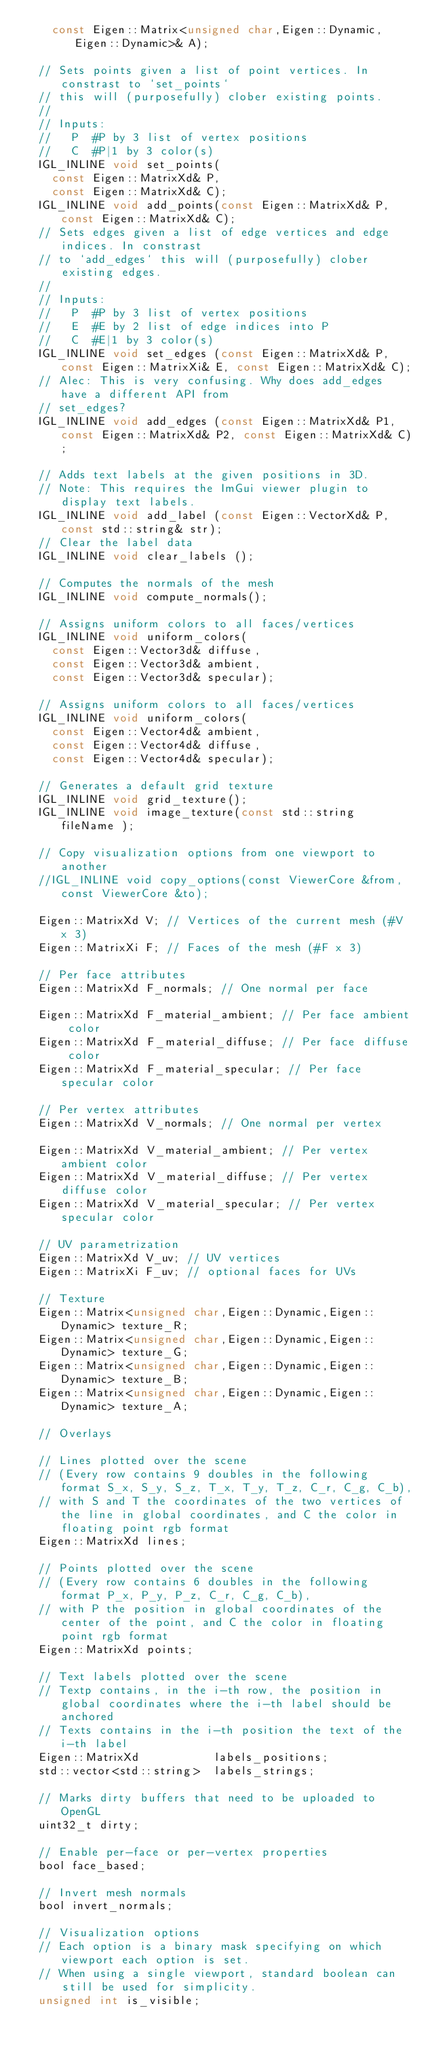Convert code to text. <code><loc_0><loc_0><loc_500><loc_500><_C_>    const Eigen::Matrix<unsigned char,Eigen::Dynamic,Eigen::Dynamic>& A);

  // Sets points given a list of point vertices. In constrast to `set_points`
  // this will (purposefully) clober existing points.
  //
  // Inputs:
  //   P  #P by 3 list of vertex positions
  //   C  #P|1 by 3 color(s)
  IGL_INLINE void set_points(
    const Eigen::MatrixXd& P,
    const Eigen::MatrixXd& C);
  IGL_INLINE void add_points(const Eigen::MatrixXd& P,  const Eigen::MatrixXd& C);
  // Sets edges given a list of edge vertices and edge indices. In constrast
  // to `add_edges` this will (purposefully) clober existing edges.
  //
  // Inputs:
  //   P  #P by 3 list of vertex positions
  //   E  #E by 2 list of edge indices into P
  //   C  #E|1 by 3 color(s)
  IGL_INLINE void set_edges (const Eigen::MatrixXd& P, const Eigen::MatrixXi& E, const Eigen::MatrixXd& C);
  // Alec: This is very confusing. Why does add_edges have a different API from
  // set_edges?
  IGL_INLINE void add_edges (const Eigen::MatrixXd& P1, const Eigen::MatrixXd& P2, const Eigen::MatrixXd& C);

  // Adds text labels at the given positions in 3D.
  // Note: This requires the ImGui viewer plugin to display text labels.
  IGL_INLINE void add_label (const Eigen::VectorXd& P,  const std::string& str);
  // Clear the label data
  IGL_INLINE void clear_labels ();

  // Computes the normals of the mesh
  IGL_INLINE void compute_normals();

  // Assigns uniform colors to all faces/vertices
  IGL_INLINE void uniform_colors(
    const Eigen::Vector3d& diffuse,
    const Eigen::Vector3d& ambient,
    const Eigen::Vector3d& specular);

  // Assigns uniform colors to all faces/vertices
  IGL_INLINE void uniform_colors(
    const Eigen::Vector4d& ambient,
    const Eigen::Vector4d& diffuse,
    const Eigen::Vector4d& specular);

  // Generates a default grid texture
  IGL_INLINE void grid_texture();
  IGL_INLINE void image_texture(const std::string fileName );

  // Copy visualization options from one viewport to another
  //IGL_INLINE void copy_options(const ViewerCore &from, const ViewerCore &to);

  Eigen::MatrixXd V; // Vertices of the current mesh (#V x 3)
  Eigen::MatrixXi F; // Faces of the mesh (#F x 3)

  // Per face attributes
  Eigen::MatrixXd F_normals; // One normal per face

  Eigen::MatrixXd F_material_ambient; // Per face ambient color
  Eigen::MatrixXd F_material_diffuse; // Per face diffuse color
  Eigen::MatrixXd F_material_specular; // Per face specular color

  // Per vertex attributes
  Eigen::MatrixXd V_normals; // One normal per vertex

  Eigen::MatrixXd V_material_ambient; // Per vertex ambient color
  Eigen::MatrixXd V_material_diffuse; // Per vertex diffuse color
  Eigen::MatrixXd V_material_specular; // Per vertex specular color

  // UV parametrization
  Eigen::MatrixXd V_uv; // UV vertices
  Eigen::MatrixXi F_uv; // optional faces for UVs

  // Texture
  Eigen::Matrix<unsigned char,Eigen::Dynamic,Eigen::Dynamic> texture_R;
  Eigen::Matrix<unsigned char,Eigen::Dynamic,Eigen::Dynamic> texture_G;
  Eigen::Matrix<unsigned char,Eigen::Dynamic,Eigen::Dynamic> texture_B;
  Eigen::Matrix<unsigned char,Eigen::Dynamic,Eigen::Dynamic> texture_A;

  // Overlays

  // Lines plotted over the scene
  // (Every row contains 9 doubles in the following format S_x, S_y, S_z, T_x, T_y, T_z, C_r, C_g, C_b),
  // with S and T the coordinates of the two vertices of the line in global coordinates, and C the color in floating point rgb format
  Eigen::MatrixXd lines;

  // Points plotted over the scene
  // (Every row contains 6 doubles in the following format P_x, P_y, P_z, C_r, C_g, C_b),
  // with P the position in global coordinates of the center of the point, and C the color in floating point rgb format
  Eigen::MatrixXd points;

  // Text labels plotted over the scene
  // Textp contains, in the i-th row, the position in global coordinates where the i-th label should be anchored
  // Texts contains in the i-th position the text of the i-th label
  Eigen::MatrixXd           labels_positions;
  std::vector<std::string>  labels_strings;

  // Marks dirty buffers that need to be uploaded to OpenGL
  uint32_t dirty;

  // Enable per-face or per-vertex properties
  bool face_based;

  // Invert mesh normals
  bool invert_normals;

  // Visualization options
  // Each option is a binary mask specifying on which viewport each option is set.
  // When using a single viewport, standard boolean can still be used for simplicity.
  unsigned int is_visible;</code> 